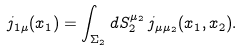<formula> <loc_0><loc_0><loc_500><loc_500>j _ { 1 \mu } ( x _ { 1 } ) = \int _ { \Sigma _ { 2 } } d S ^ { \mu _ { 2 } } _ { 2 } \, j _ { \mu \mu _ { 2 } } ( x _ { 1 } , x _ { 2 } ) .</formula> 